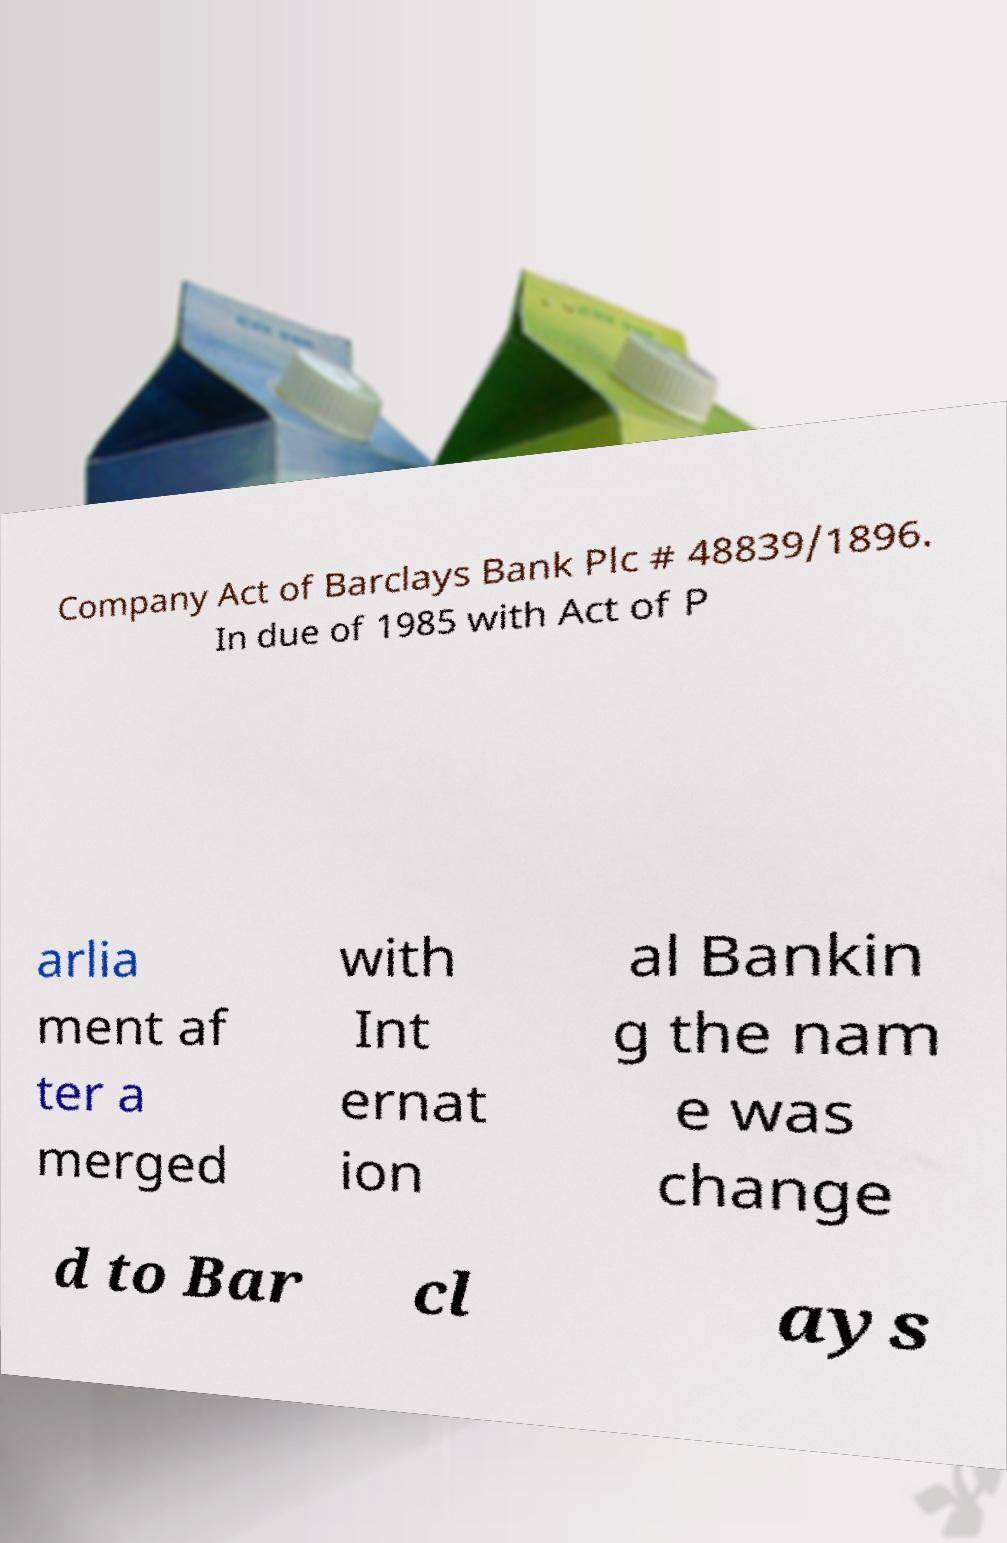Please read and relay the text visible in this image. What does it say? Company Act of Barclays Bank Plc # 48839/1896. In due of 1985 with Act of P arlia ment af ter a merged with Int ernat ion al Bankin g the nam e was change d to Bar cl ays 